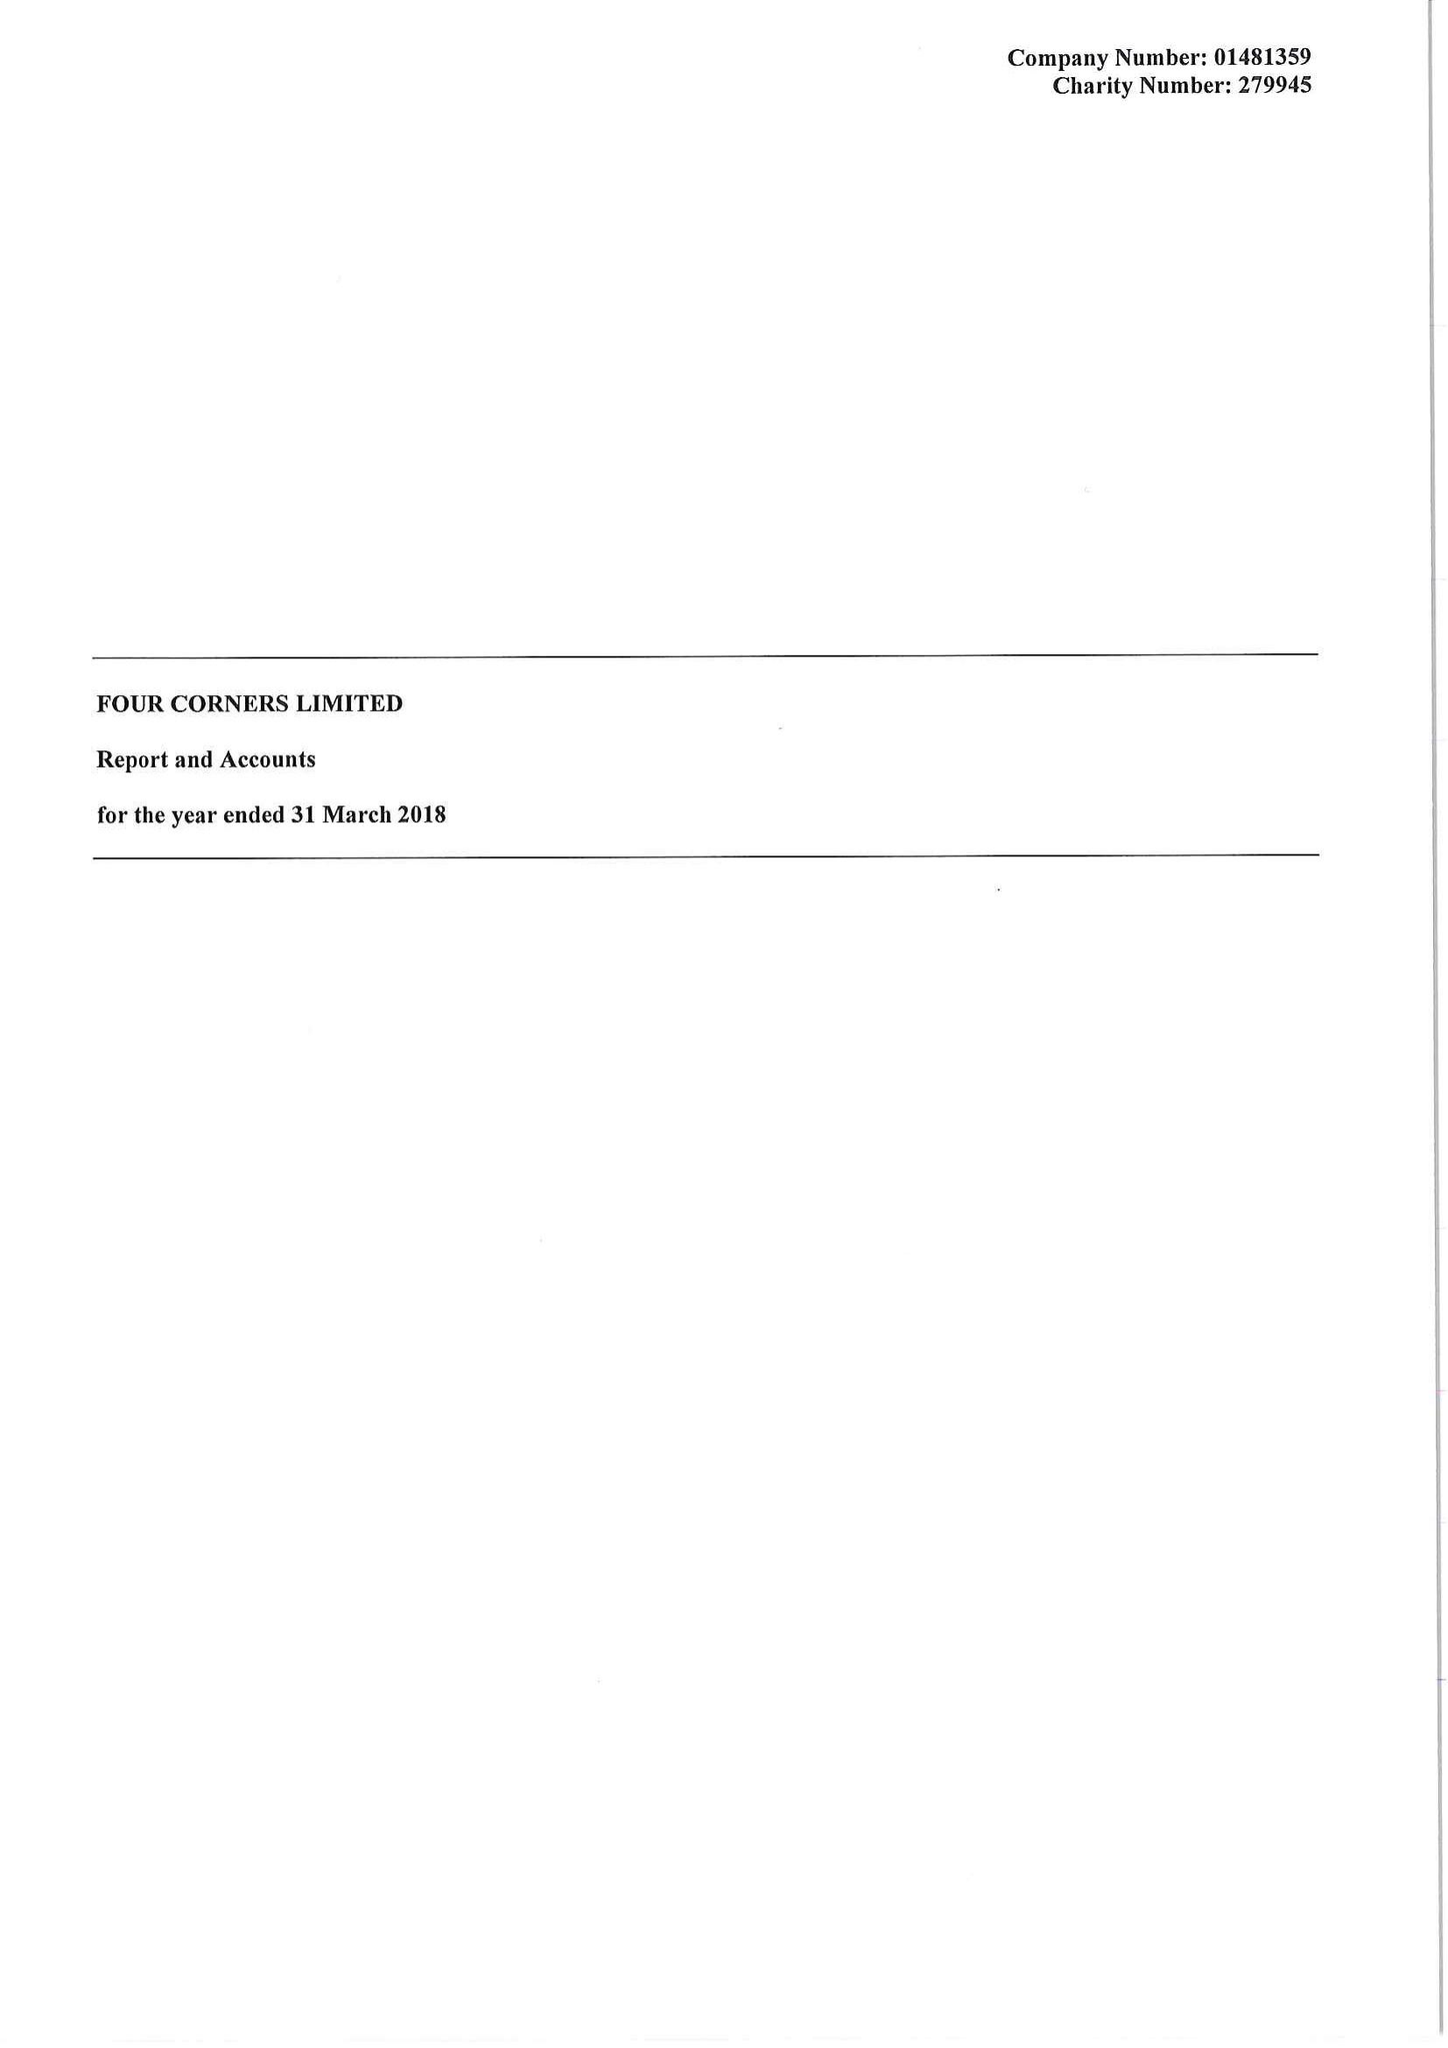What is the value for the charity_number?
Answer the question using a single word or phrase. 279945 